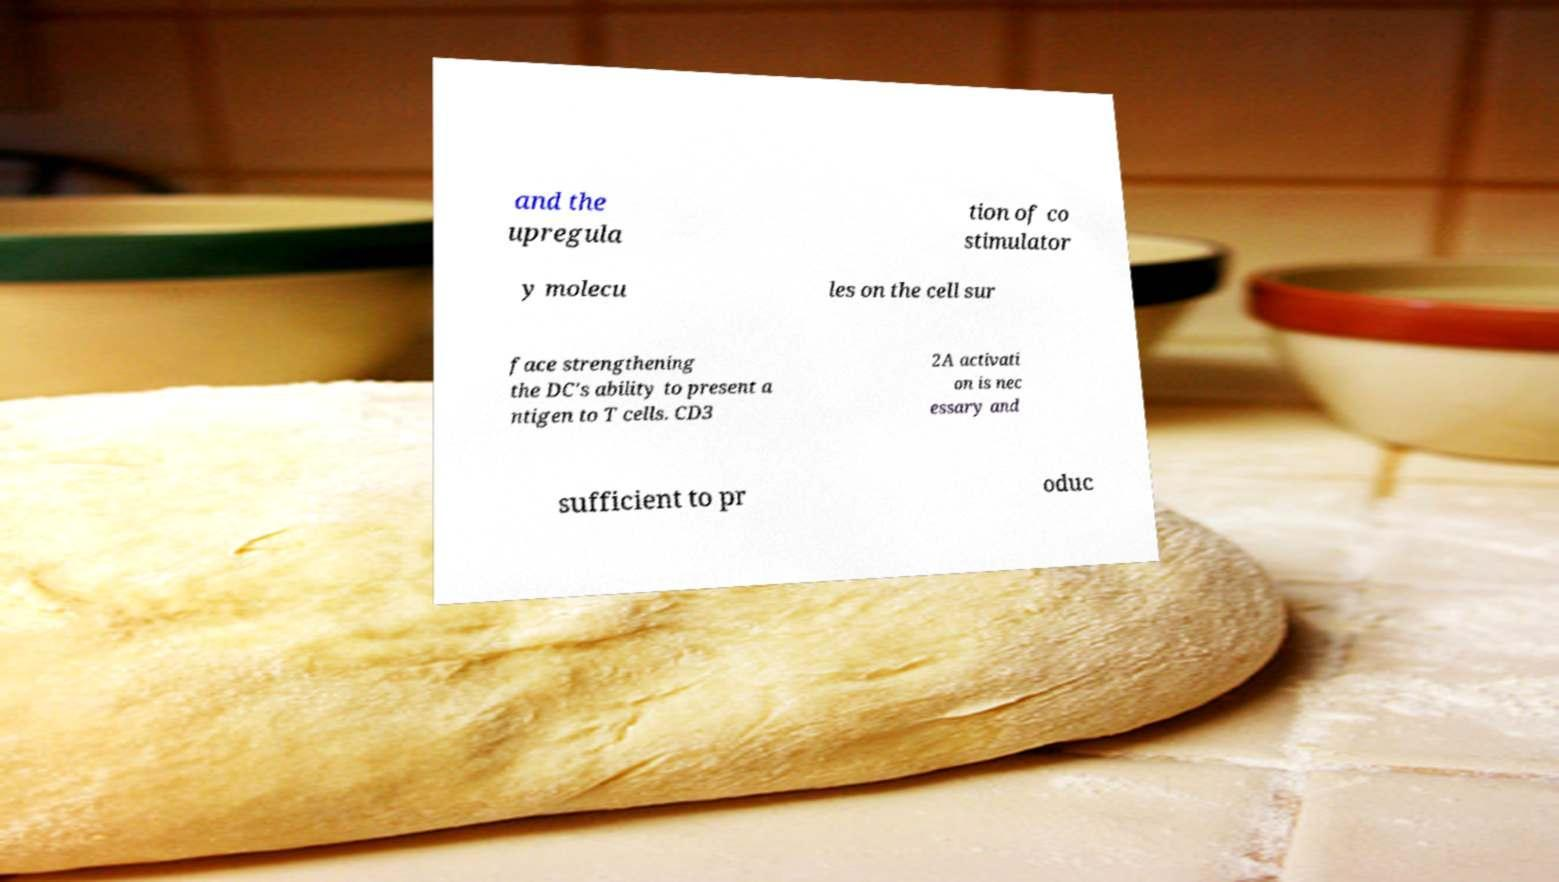For documentation purposes, I need the text within this image transcribed. Could you provide that? and the upregula tion of co stimulator y molecu les on the cell sur face strengthening the DC's ability to present a ntigen to T cells. CD3 2A activati on is nec essary and sufficient to pr oduc 